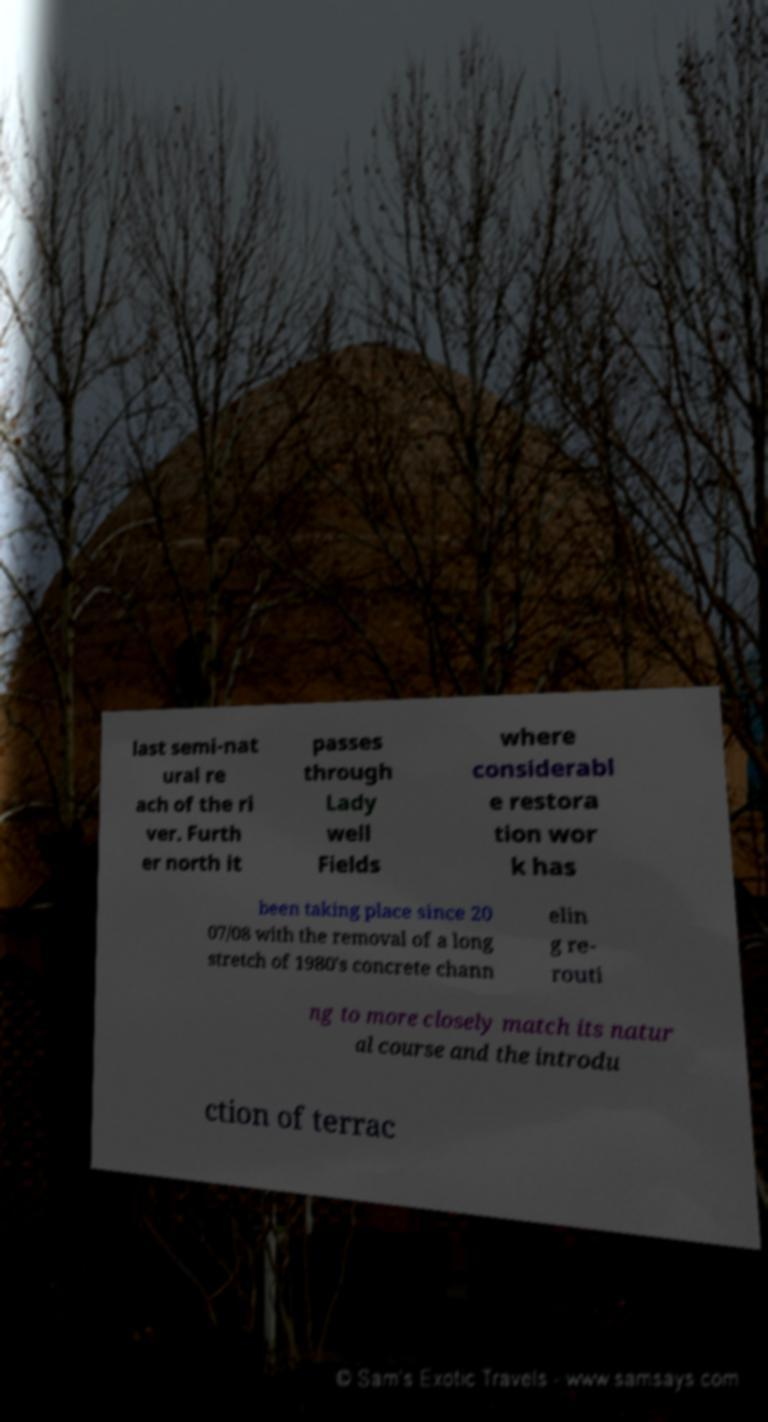I need the written content from this picture converted into text. Can you do that? last semi-nat ural re ach of the ri ver. Furth er north it passes through Lady well Fields where considerabl e restora tion wor k has been taking place since 20 07/08 with the removal of a long stretch of 1980's concrete chann elin g re- routi ng to more closely match its natur al course and the introdu ction of terrac 